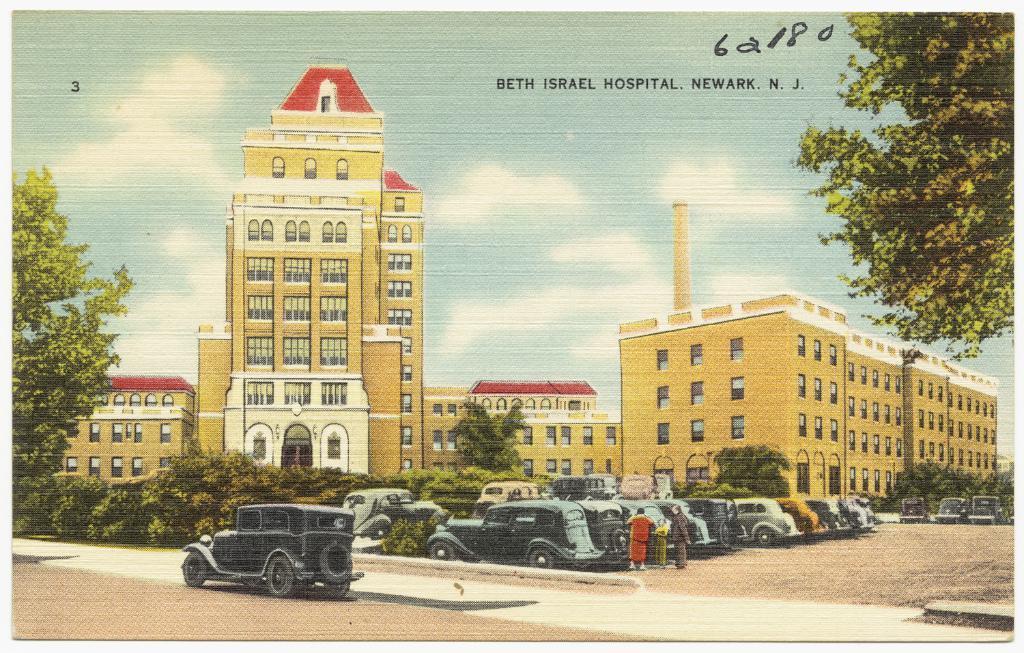Please provide a concise description of this image. This is a poster. On the poster there are buildings and trees. In the foreground there are vehicles and there are three people standing. At the top there is sky and there are clouds and there is text. At the bottom there is a road and there is ground. 